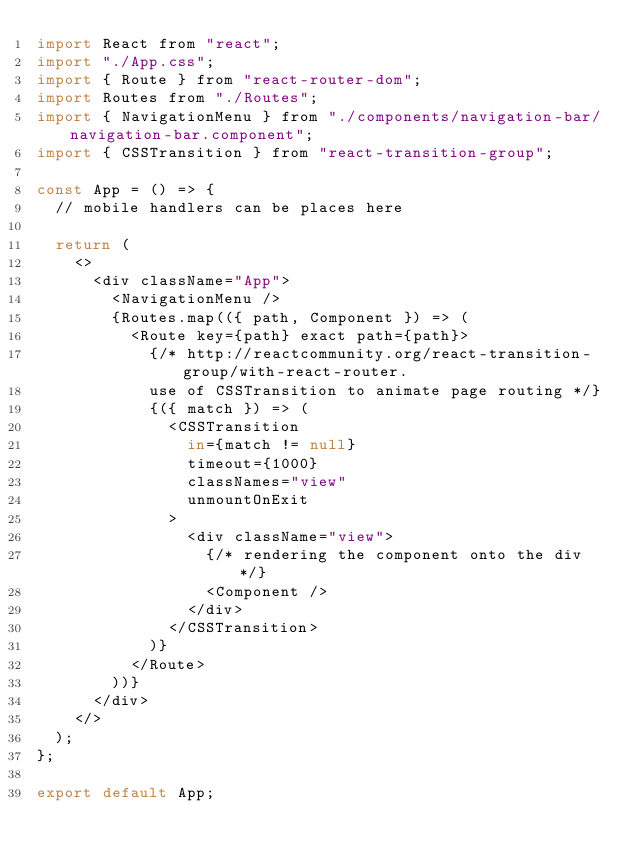<code> <loc_0><loc_0><loc_500><loc_500><_JavaScript_>import React from "react";
import "./App.css";
import { Route } from "react-router-dom";
import Routes from "./Routes";
import { NavigationMenu } from "./components/navigation-bar/navigation-bar.component";
import { CSSTransition } from "react-transition-group";

const App = () => {
  // mobile handlers can be places here

  return (
    <>
      <div className="App">
        <NavigationMenu />
        {Routes.map(({ path, Component }) => (
          <Route key={path} exact path={path}>
            {/* http://reactcommunity.org/react-transition-group/with-react-router.
            use of CSSTransition to animate page routing */}
            {({ match }) => (
              <CSSTransition
                in={match != null}
                timeout={1000}
                classNames="view"
                unmountOnExit
              >
                <div className="view">
                  {/* rendering the component onto the div */}
                  <Component />
                </div>
              </CSSTransition>
            )}
          </Route>
        ))}
      </div>
    </>
  );
};

export default App;
</code> 